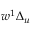Convert formula to latex. <formula><loc_0><loc_0><loc_500><loc_500>w ^ { 1 } \Delta _ { u }</formula> 